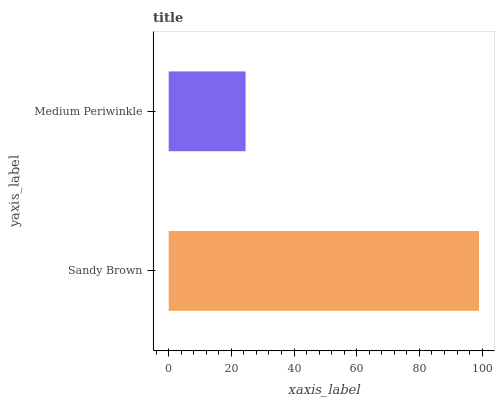Is Medium Periwinkle the minimum?
Answer yes or no. Yes. Is Sandy Brown the maximum?
Answer yes or no. Yes. Is Medium Periwinkle the maximum?
Answer yes or no. No. Is Sandy Brown greater than Medium Periwinkle?
Answer yes or no. Yes. Is Medium Periwinkle less than Sandy Brown?
Answer yes or no. Yes. Is Medium Periwinkle greater than Sandy Brown?
Answer yes or no. No. Is Sandy Brown less than Medium Periwinkle?
Answer yes or no. No. Is Sandy Brown the high median?
Answer yes or no. Yes. Is Medium Periwinkle the low median?
Answer yes or no. Yes. Is Medium Periwinkle the high median?
Answer yes or no. No. Is Sandy Brown the low median?
Answer yes or no. No. 